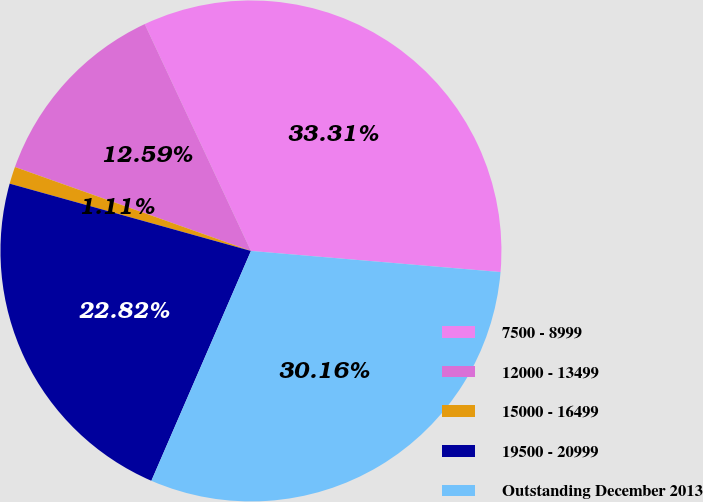Convert chart to OTSL. <chart><loc_0><loc_0><loc_500><loc_500><pie_chart><fcel>7500 - 8999<fcel>12000 - 13499<fcel>15000 - 16499<fcel>19500 - 20999<fcel>Outstanding December 2013<nl><fcel>33.31%<fcel>12.59%<fcel>1.11%<fcel>22.82%<fcel>30.16%<nl></chart> 